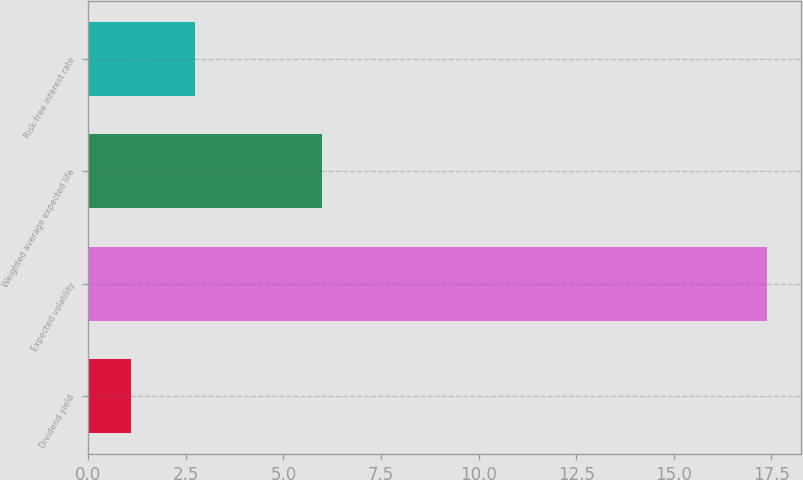<chart> <loc_0><loc_0><loc_500><loc_500><bar_chart><fcel>Dividend yield<fcel>Expected volatility<fcel>Weighted average expected life<fcel>Risk-free interest rate<nl><fcel>1.1<fcel>17.4<fcel>6<fcel>2.73<nl></chart> 